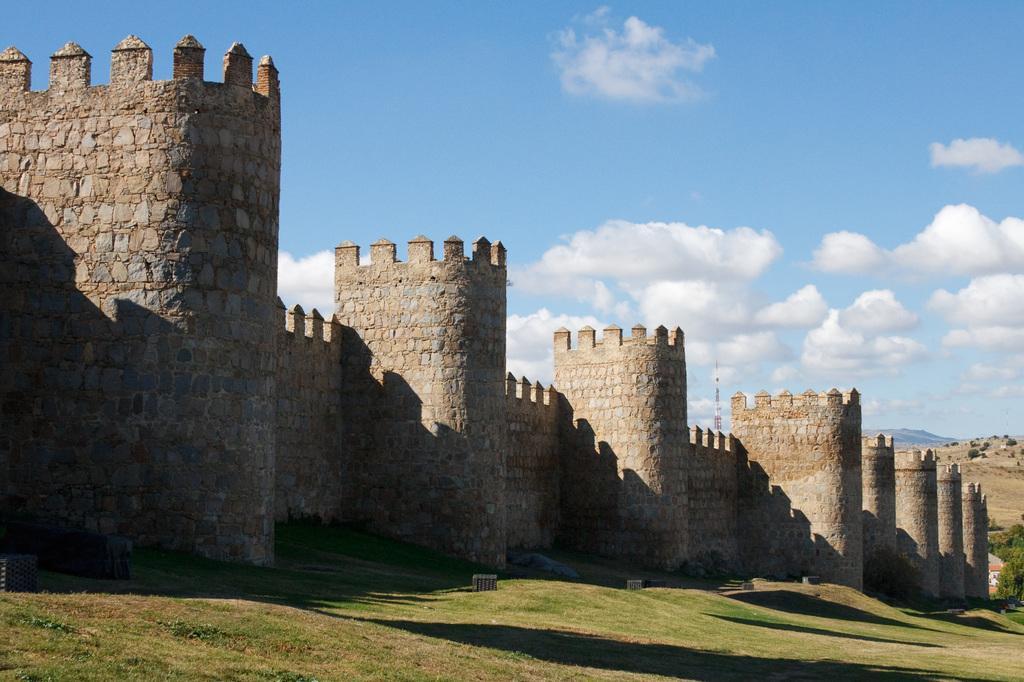In one or two sentences, can you explain what this image depicts? In this image, we can see forest, trees and a tower and we can see some objects on the ground. At the top, there are clouds in the sky. 